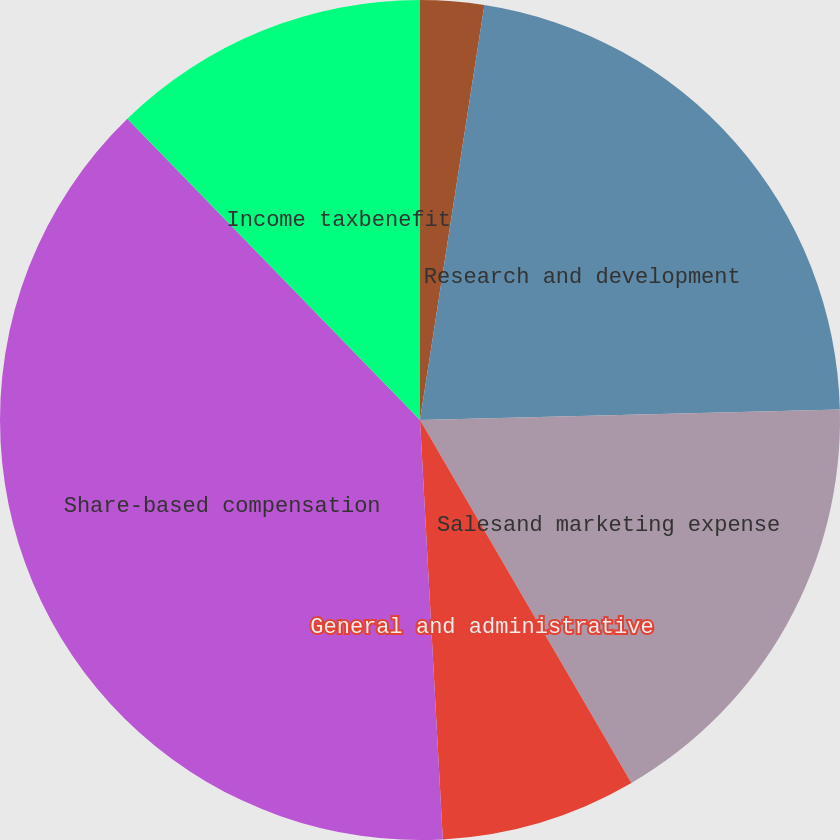Convert chart to OTSL. <chart><loc_0><loc_0><loc_500><loc_500><pie_chart><fcel>Cost of maintenance and<fcel>Research and development<fcel>Salesand marketing expense<fcel>General and administrative<fcel>Share-based compensation<fcel>Income taxbenefit<nl><fcel>2.45%<fcel>22.15%<fcel>17.0%<fcel>7.53%<fcel>38.59%<fcel>12.27%<nl></chart> 